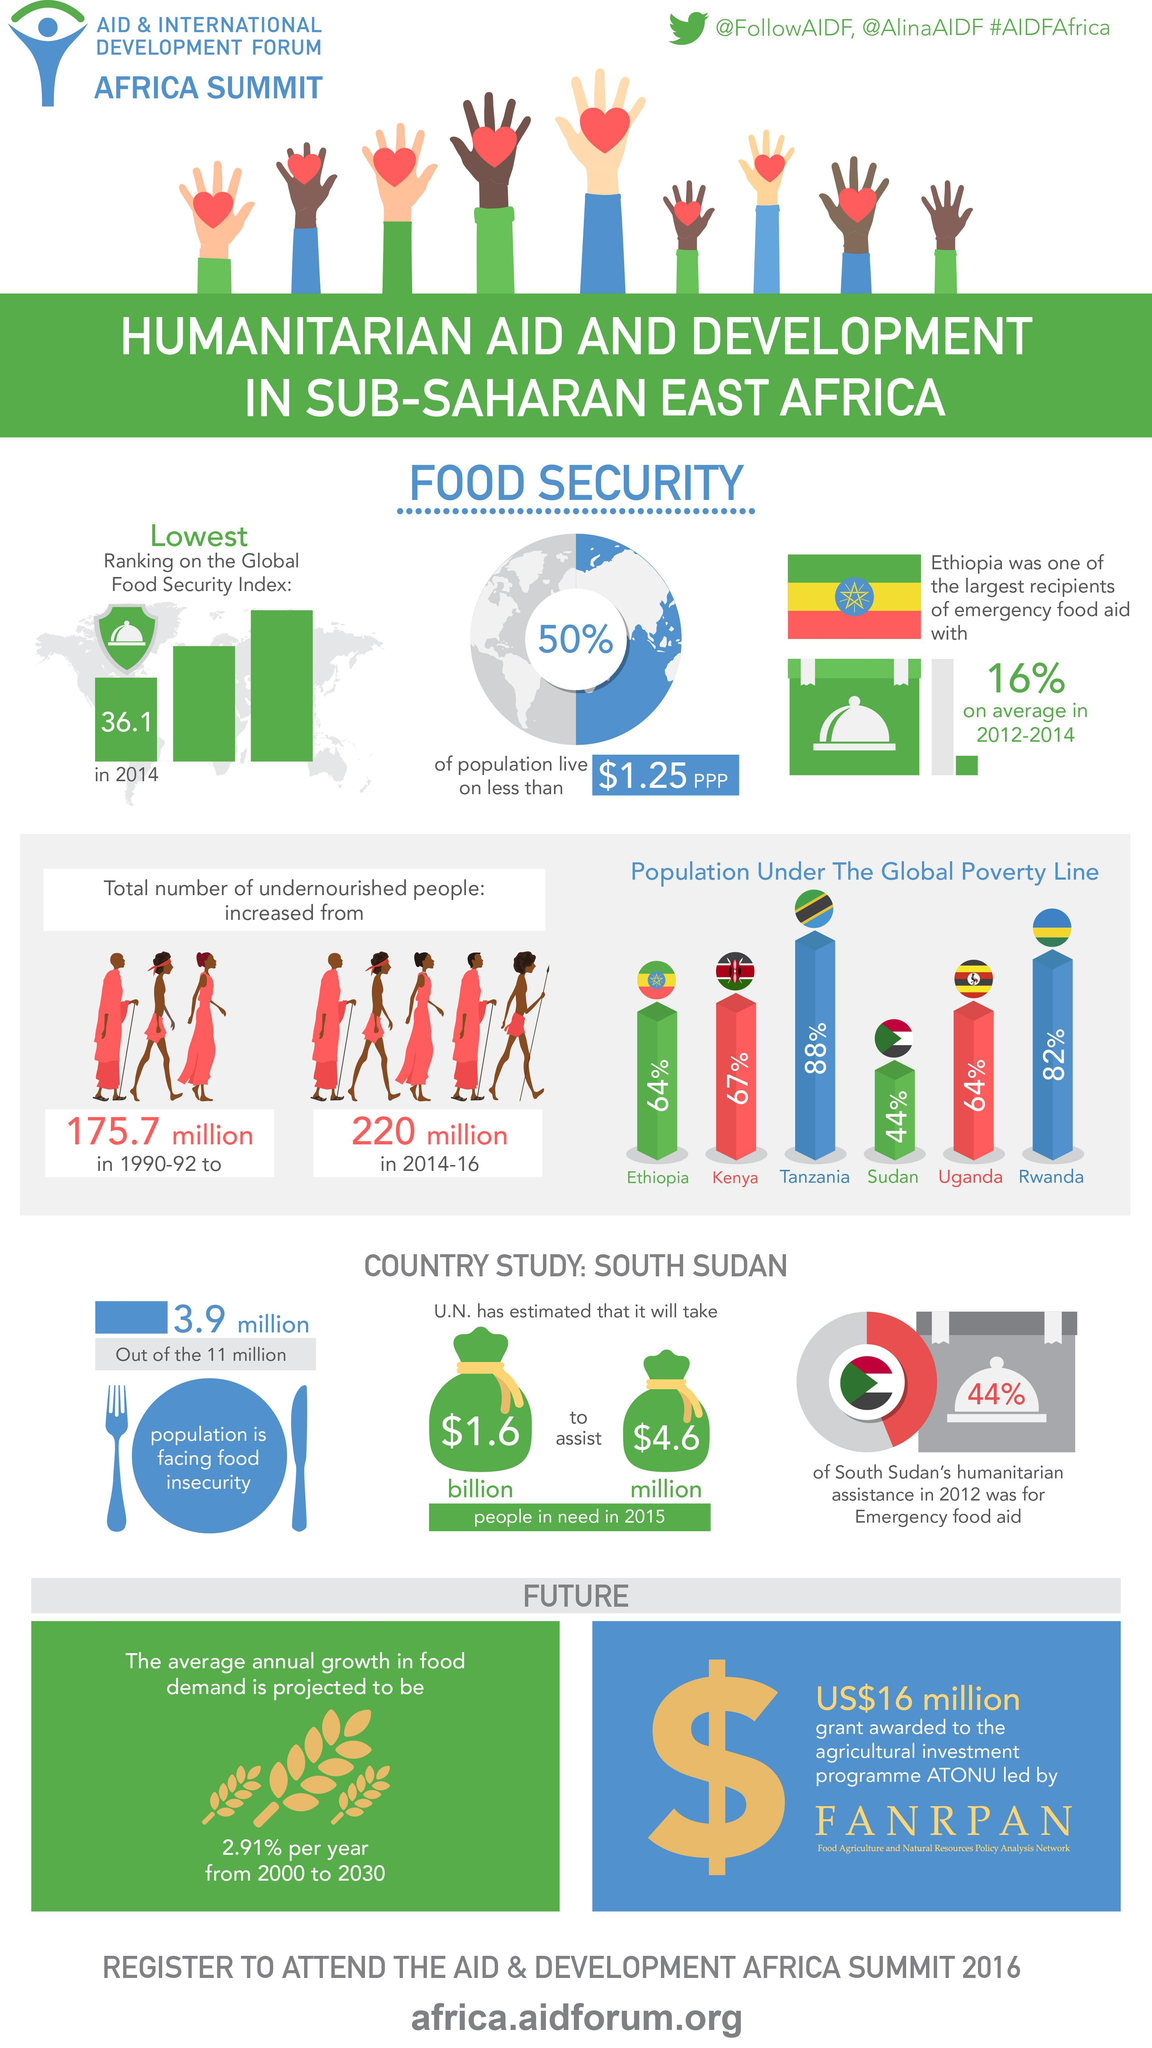Draw attention to some important aspects in this diagram. The number of undernourished people between 2014-16 was 44.3 million, which is significantly lower than the 77.9 million people who were considered undernourished during the period of 1990-92. There are 6 countries that are below the global poverty line and are featured in this infographic. In 2012, only 44% of South Sudan's humanitarian assistance was for emergency food aid, while 56% of the assistance was for non-emergency purposes. 